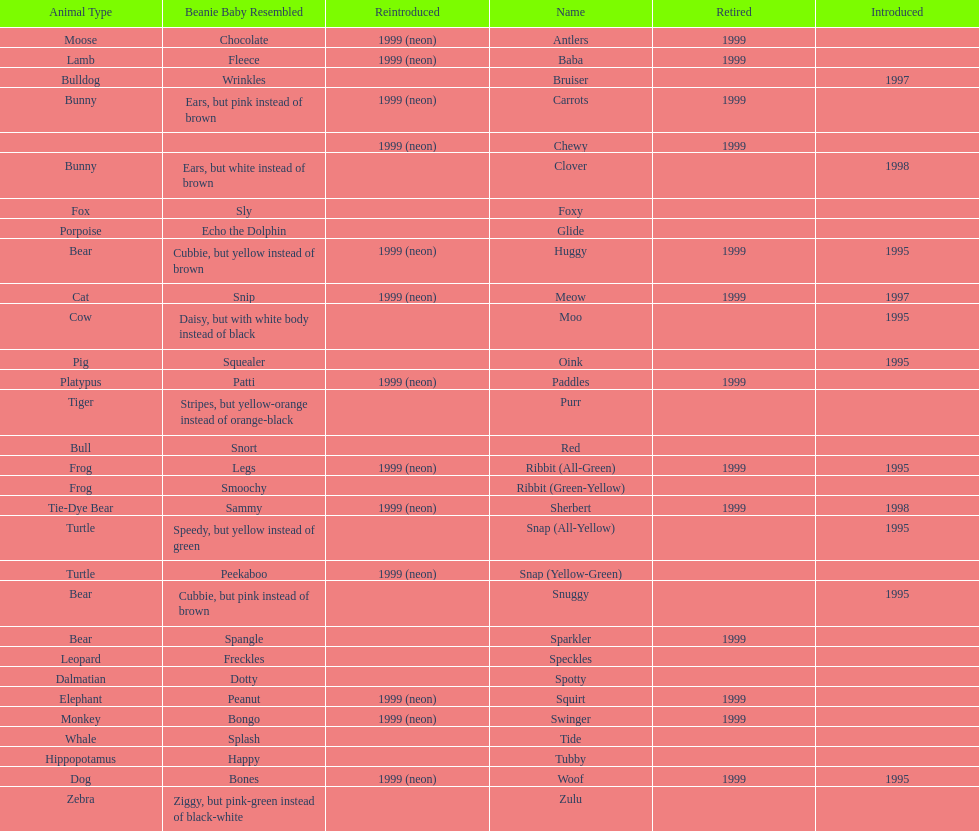Tell me the number of pillow pals reintroduced in 1999. 13. 